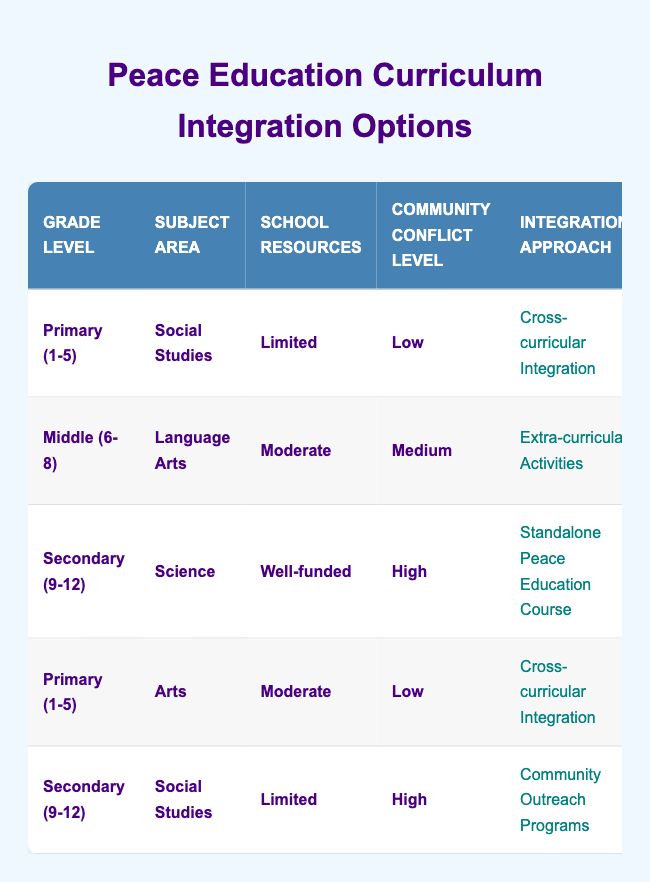What approach is recommended for Primary (1-5) students in Social Studies with Limited resources and Low community conflict? The table shows that for Primary (1-5) students studying Social Studies with Limited resources and Low community conflict, the recommended Integration Approach is "Cross-curricular Integration." This specific recommendation is based on the first row of data in the table.
Answer: Cross-curricular Integration Which teaching method is suggested for Secondary (9-12) students studying Science in a Well-funded environment with High community conflict? The table indicates that for Secondary (9-12) students in Science, where the school is Well-funded and community conflict is High, the suggested Teaching Method is "Service Learning Projects." This is found in the third row of the data.
Answer: Service Learning Projects Is it true that all Middle (6-8) students studying Language Arts with Moderate resources will require Guest Speakers and Experts as resources? According to the table, Middle (6-8) students studying Language Arts with Moderate resources will require "Digital Media and Online Resources," and not Guest Speakers and Experts. Therefore, this statement is false.
Answer: False What are the assessment techniques for Primary (1-5) Arts students in a Moderate resources environment with Low community conflict? The table states that for Primary (1-5) Arts students in a Moderate resources setting and Low community conflict, the recommended Assessment Techniques are "Reflective Journals." This information can be found in the fourth row of the table.
Answer: Reflective Journals For Secondary (9-12) students studying Social Studies with Limited resources and High conflict, what are the required resources? According to the table, Secondary (9-12) students studying Social Studies in Limited resources during High community conflict will require "Guest Speakers and Experts." This data is available in the fifth row.
Answer: Guest Speakers and Experts What is the average level of community conflict among the different grade levels listed? In the table, the levels of community conflict are: Low, Medium, High, Low, and High. We can assign numerical values: Low = 1, Medium = 2, High = 3. The average can be calculated by first summing these values (1 + 2 + 3 + 1 + 3 = 10) and then dividing by the number of entries (5), resulting in an average of 10/5 = 2.
Answer: 2 Which integration approach is used for Primary (1-5) students in Social Studies if resources are Moderate instead of Limited? The table does not provide a direct entry for Primary (1-5) Social Studies with Moderate resources; therefore, we need to refer to a similar group. Based on the data, it suggests "Cross-curricular Integration" could still be a viable choice, but it isn't definitively stated. A direct entry for this condition does not exist in the table.
Answer: Not specified in the table How many different assessment techniques are recommended for Secondary (9-12) students studying Science? From the table, Secondary (9-12) students studying Science have their designated Assessment Technique as "Community Impact Reports." Since this is the only recommendation shown for this specific condition in the table, we conclude that there is one.
Answer: 1 Which resource requirement for Middle (6-8) Language Arts students indicates a focus on digital technology? The recommended resource for Middle (6-8) Language Arts students is "Digital Media and Online Resources," indicating a focus on digital technology. This is found in the second row of the table.
Answer: Digital Media and Online Resources 